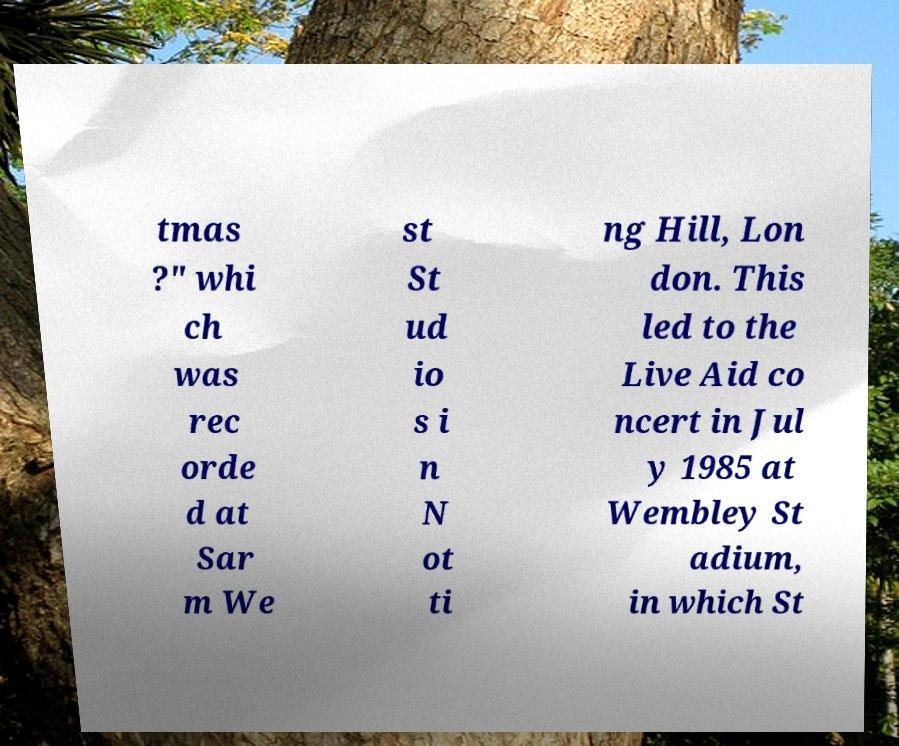I need the written content from this picture converted into text. Can you do that? tmas ?" whi ch was rec orde d at Sar m We st St ud io s i n N ot ti ng Hill, Lon don. This led to the Live Aid co ncert in Jul y 1985 at Wembley St adium, in which St 